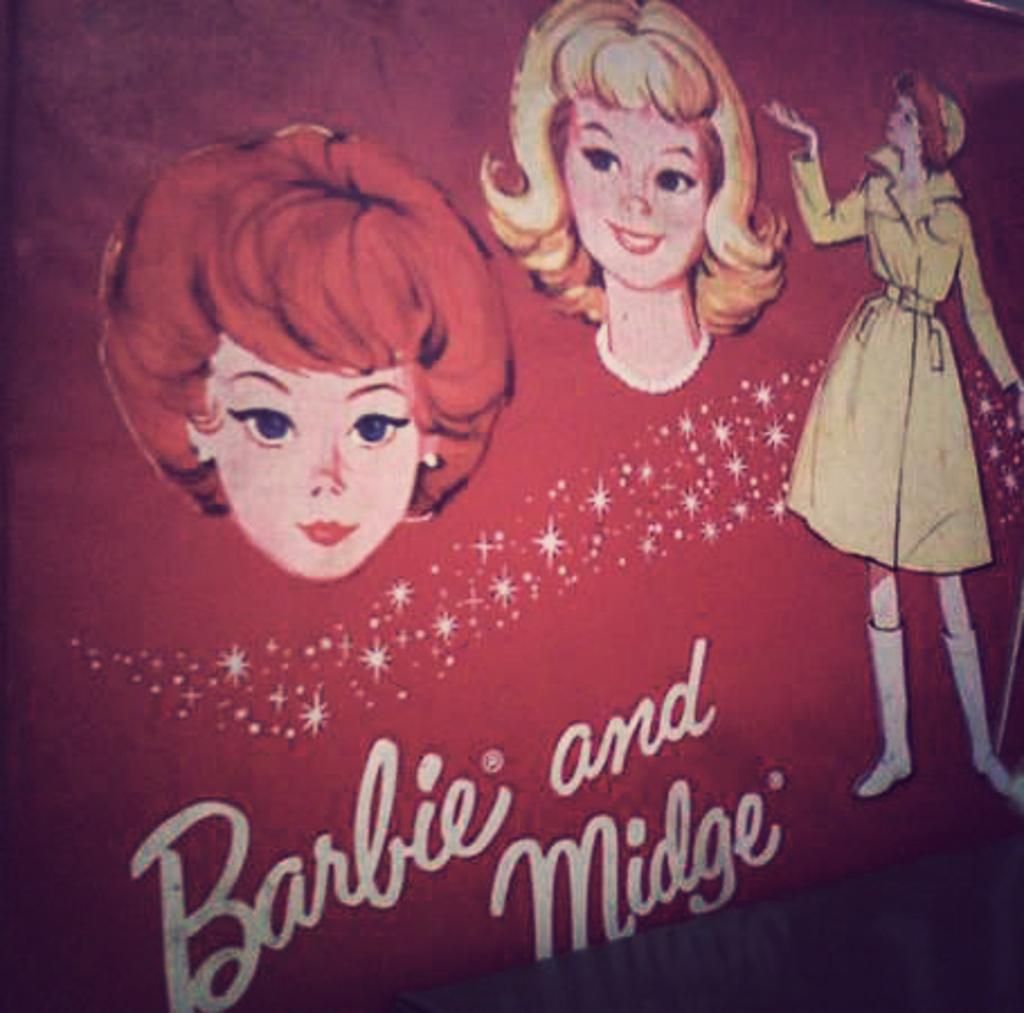Describe this image in one or two sentences. In this image we can see a poster with some text and images. 